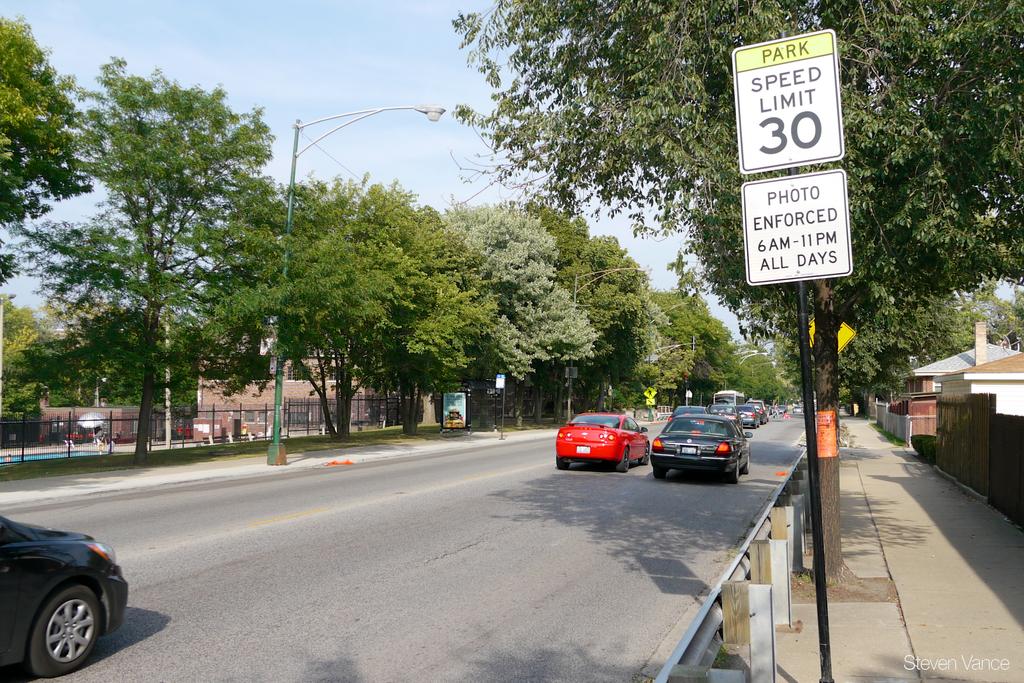What is the speed limit?
Make the answer very short. 30. 30 top speed?
Your answer should be compact. Yes. 